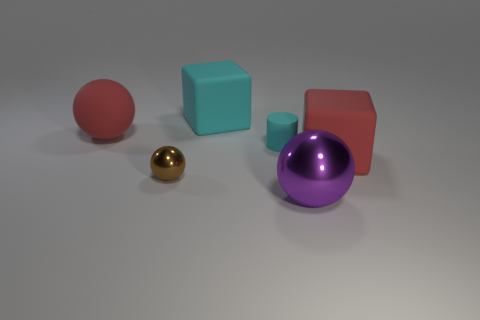Does the small brown thing have the same shape as the large purple metal object?
Provide a succinct answer. Yes. Is there anything else that has the same material as the big purple ball?
Offer a very short reply. Yes. How many large objects are in front of the tiny cyan thing and behind the tiny sphere?
Ensure brevity in your answer.  1. What color is the big cube behind the block to the right of the large metallic thing?
Make the answer very short. Cyan. Is the number of small metal things that are behind the tiny ball the same as the number of red rubber objects?
Provide a short and direct response. No. There is a large red thing in front of the large red object that is to the left of the large purple thing; how many tiny rubber cylinders are in front of it?
Offer a very short reply. 0. The big rubber cube that is left of the red matte cube is what color?
Ensure brevity in your answer.  Cyan. There is a object that is to the right of the tiny brown metallic object and to the left of the tiny cyan cylinder; what is it made of?
Provide a short and direct response. Rubber. There is a large sphere to the left of the tiny cyan cylinder; how many large shiny spheres are to the right of it?
Keep it short and to the point. 1. The big cyan object is what shape?
Your answer should be compact. Cube. 